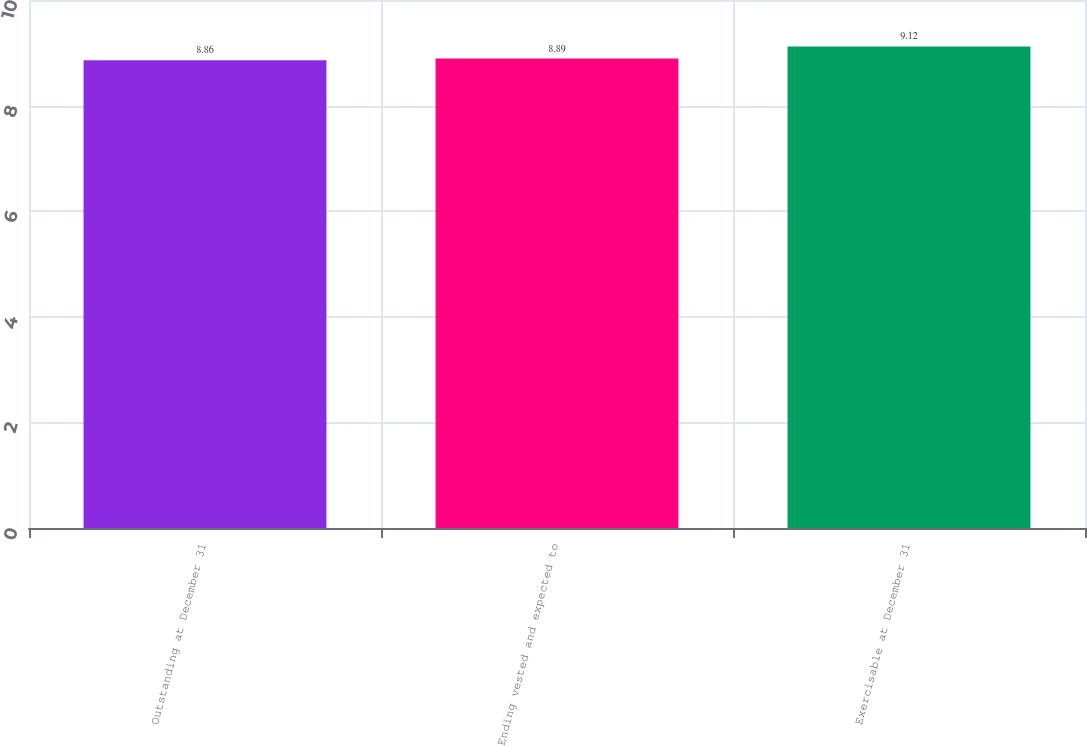<chart> <loc_0><loc_0><loc_500><loc_500><bar_chart><fcel>Outstanding at December 31<fcel>Ending vested and expected to<fcel>Exercisable at December 31<nl><fcel>8.86<fcel>8.89<fcel>9.12<nl></chart> 